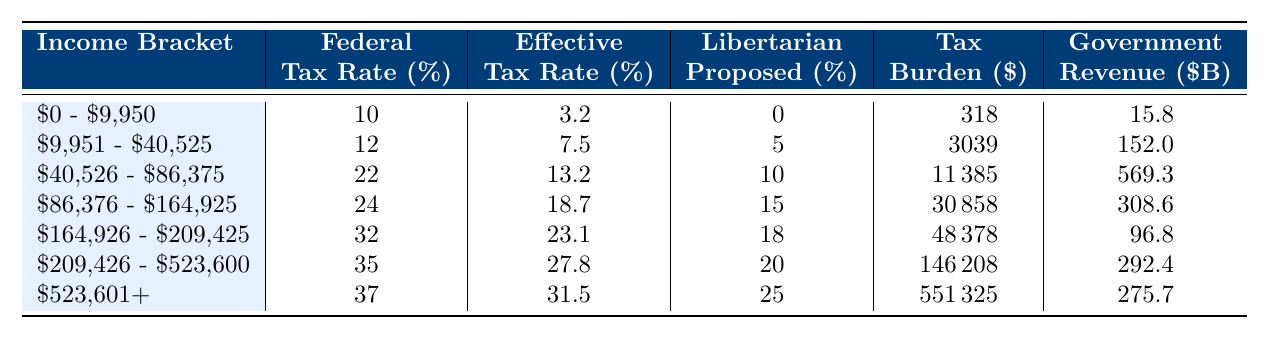What is the federal tax rate for the income bracket of $40,526 - $86,375? The table shows that the federal tax rate for the income bracket of $40,526 - $86,375 is listed directly under the "Federal Tax Rate (%)" column. The value is 22%.
Answer: 22% How much tax burden is imposed on the $164,926 - $209,425 income bracket? Referring to the table, the tax burden for the income bracket of $164,926 - $209,425 is found in the "Tax Burden ($)" column, which states the value is $48,378.
Answer: 48378 Is the effective tax rate higher for the $523,601+ income bracket compared to the $209,426 - $523,600 bracket? The effective tax rate for the $523,601+ bracket is 31.5%, while the effective tax rate for the $209,426 - $523,600 bracket is 27.8%. Since 31.5% > 27.8%, the statement is true.
Answer: Yes What is the total government revenue generated from the income brackets $9,951 - $40,525 and $40,526 - $86,375? To find the total government revenue from these two brackets, we take the values from the "Government Revenue ($ Billions)" column. Specifically, we add 152.0 (for $9,951 - $40,525) to 569.3 (for $40,526 - $86,375). This results in 152.0 + 569.3 = 721.3 billion dollars.
Answer: 721.3 What is the difference in tax burden between the income brackets $209,426 - $523,600 and $523,601+? The tax burden for $209,426 - $523,600 is 146,208, and for $523,601+, it is 551,325. The difference is calculated as 551,325 - 146,208 = 405,117.
Answer: 405117 If a libertarian proposes a tax rate of 15% for the income bracket of $86,376 - $164,925, what is the difference in proposed rates compared to the federal rate? The federal tax rate for the $86,376 - $164,925 bracket is 24%. If the libertarian proposed rate is 15%, the difference would be 24% - 15% = 9%.
Answer: 9% What is the average effective tax rate across all income brackets? To calculate the average effective tax rate, we sum up all the effective tax rates: 3.2 + 7.5 + 13.2 + 18.7 + 23.1 + 27.8 + 31.5 = 121.0. Then we divide by the number of brackets (7), so the average is 121.0 / 7 ≈ 17.29%.
Answer: 17.29% What is the highest federal tax rate listed in the table? By reviewing the "Federal Tax Rate (%)" column, the highest tax rate is found among the income brackets, which is 37% for the $523,601+ bracket.
Answer: 37% How much revenue does the $40,526 - $86,375 bracket generate compared to the $9,951 - $40,525 bracket? The 'Government Revenue ($ Billions)' for the $40,526 - $86,375 bracket is 569.3 billion, and for the $9,951 - $40,525 bracket, it is 152.0 billion. The difference is 569.3 - 152.0 = 417.3 billion, meaning it generates significantly more revenue.
Answer: 417.3 